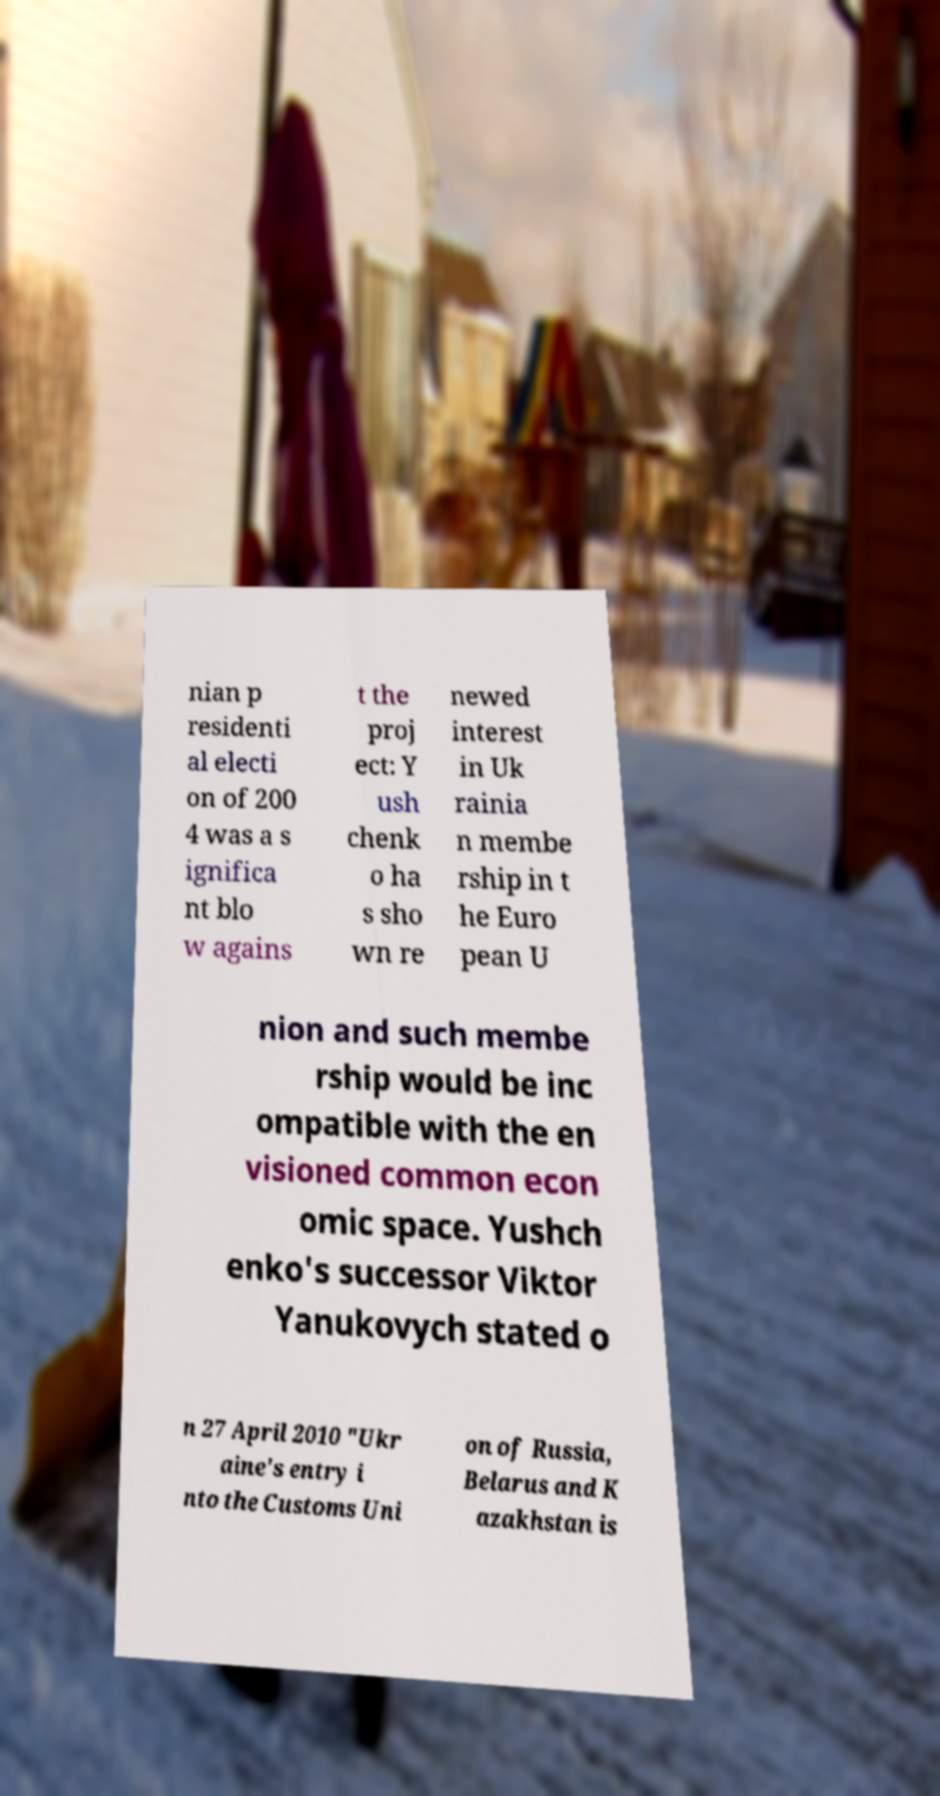Can you accurately transcribe the text from the provided image for me? nian p residenti al electi on of 200 4 was a s ignifica nt blo w agains t the proj ect: Y ush chenk o ha s sho wn re newed interest in Uk rainia n membe rship in t he Euro pean U nion and such membe rship would be inc ompatible with the en visioned common econ omic space. Yushch enko's successor Viktor Yanukovych stated o n 27 April 2010 "Ukr aine's entry i nto the Customs Uni on of Russia, Belarus and K azakhstan is 